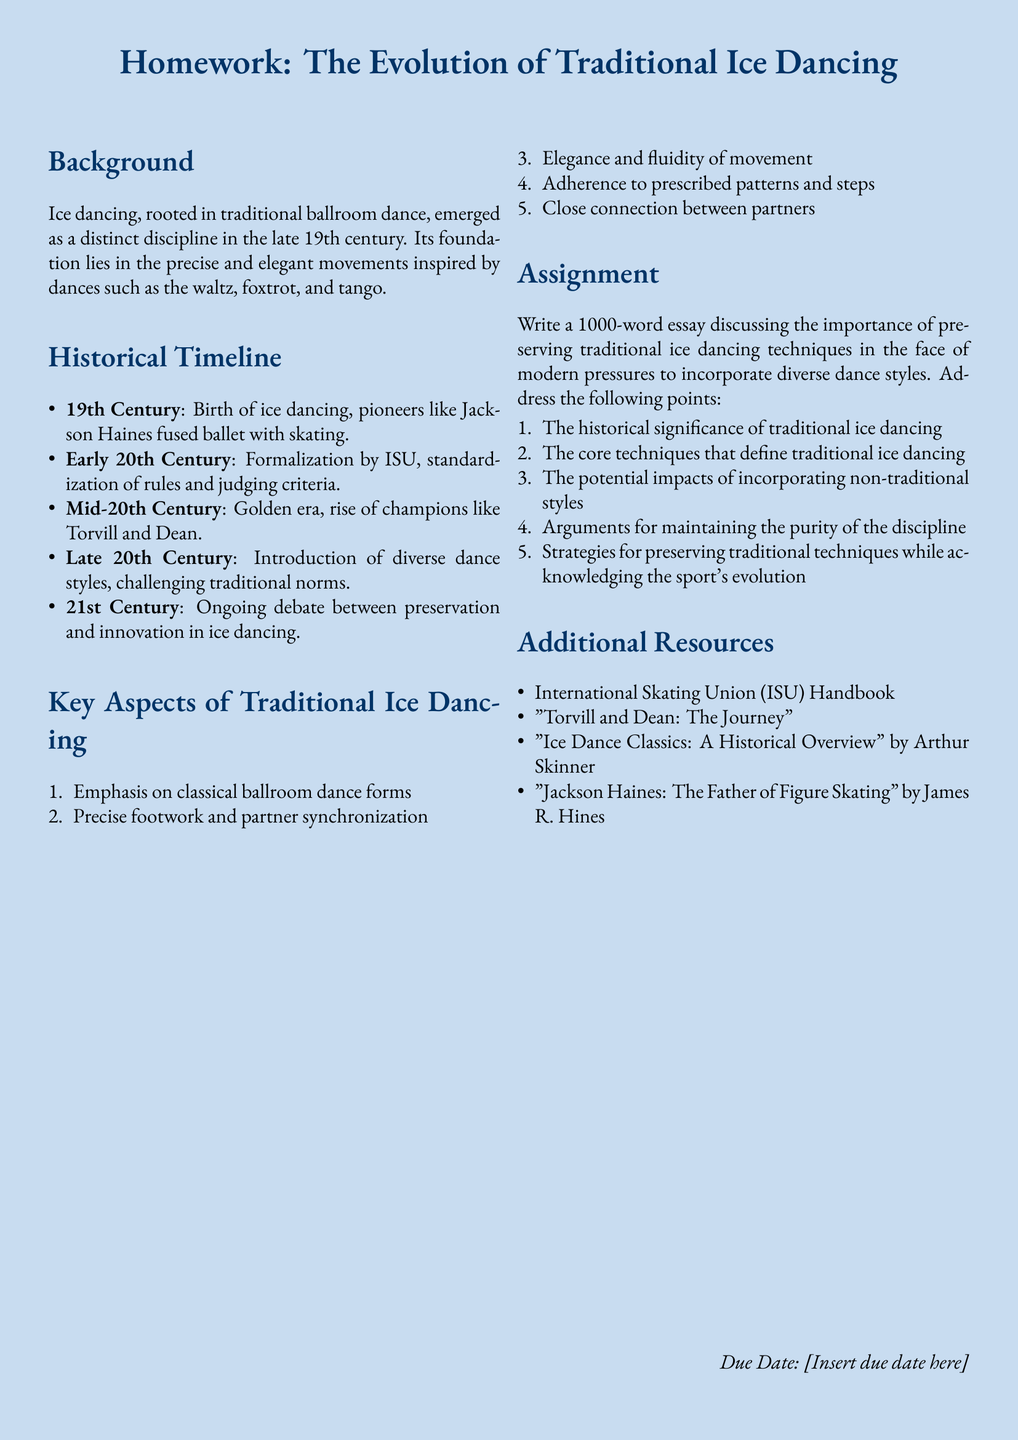What century did ice dancing emerge as a distinct discipline? Ice dancing emerged as a distinct discipline in the late 19th century.
Answer: 19th century Who were the pioneers that fused ballet with skating? The document mentions Jackson Haines as a pioneer who fused ballet with skating.
Answer: Jackson Haines What organization formalized ice dancing in the early 20th century? The document states that the International Skating Union (ISU) formalized ice dancing.
Answer: ISU What is a key aspect that defines traditional ice dancing? The document lists several key aspects, one being the emphasis on classical ballroom dance forms.
Answer: Classical ballroom dance forms What is one of the strategies for preserving traditional techniques? The document refers to strategies for preserving traditional techniques while acknowledging the sport's evolution.
Answer: Acknowledging the sport's evolution What is the historical significance of traditional ice dancing based on the document? The assignment prompts a discussion about the historical significance, indicating its importance in the evolution of the discipline.
Answer: Historical significance What was a notable period in ice dancing history mentioned in the document? The document mentions the mid-20th century as a golden era with champions like Torvill and Dean.
Answer: Mid-20th century What is the due date for the homework assignment? The document states that the due date is to be inserted, implying it is unspecified.
Answer: [Insert due date here] 